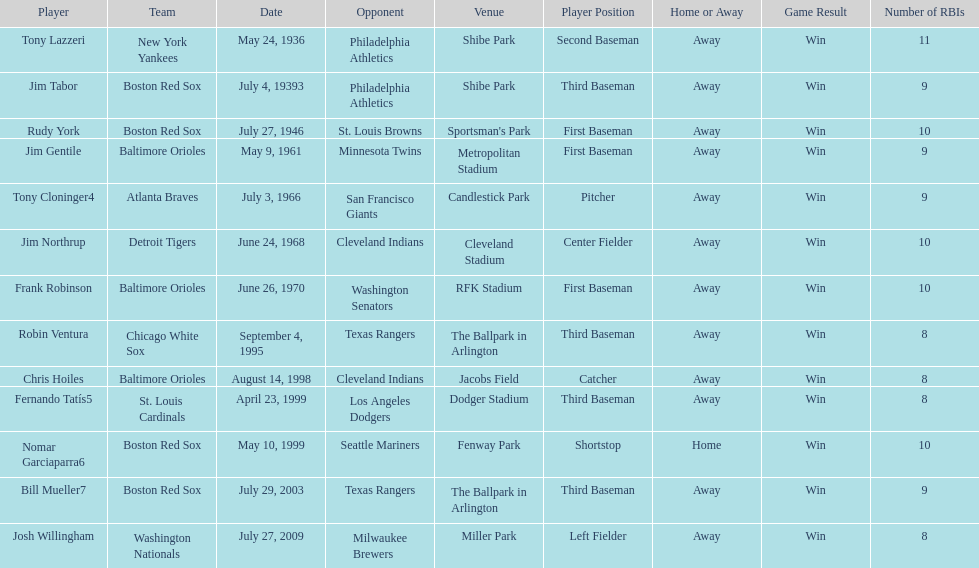What was the name of the player who accomplished this in 1999 but played for the boston red sox? Nomar Garciaparra. 